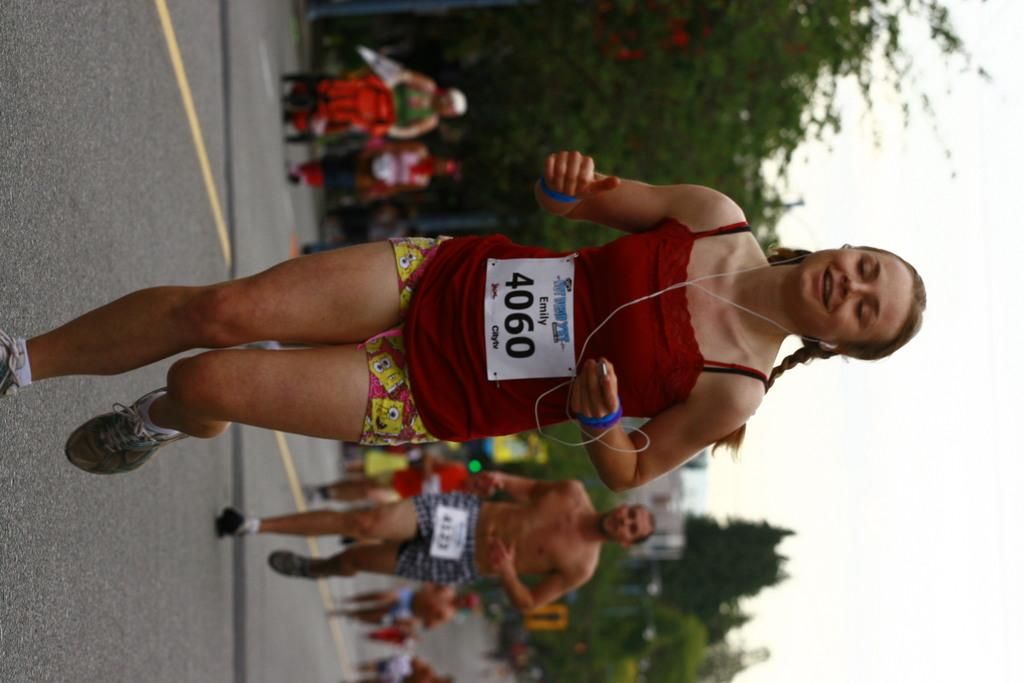<image>
Summarize the visual content of the image. A runner with the number 4060 on her participant bib. 